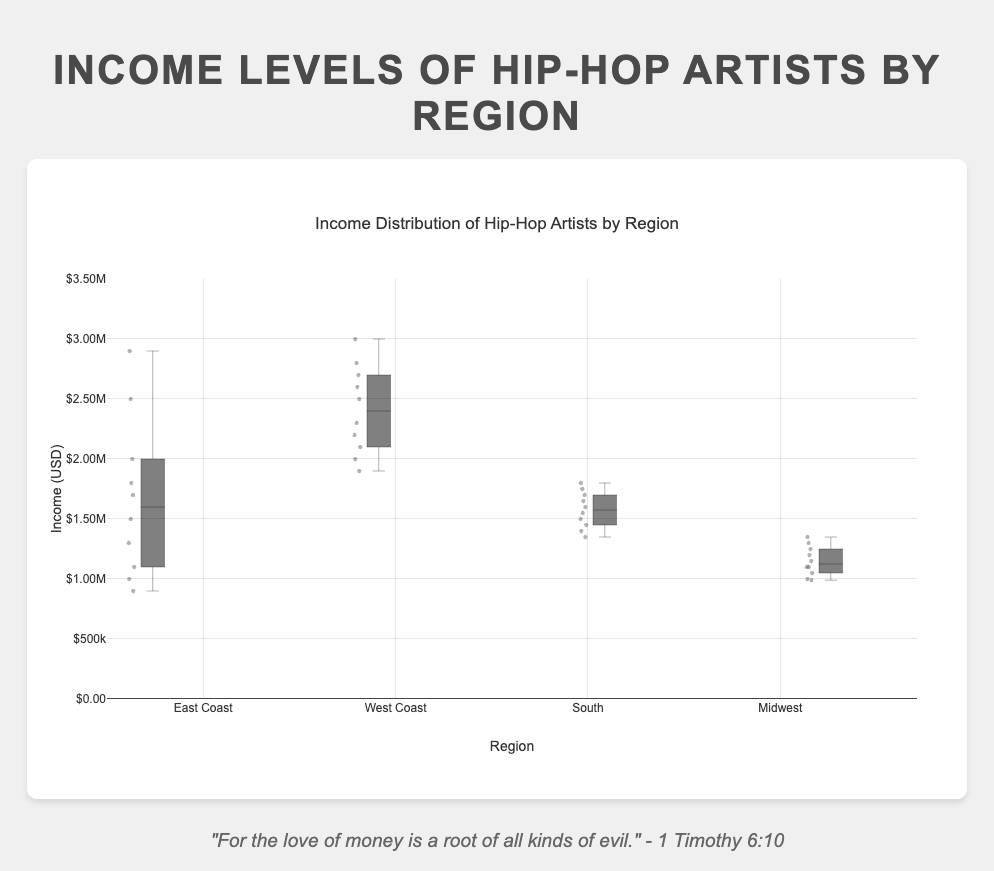What's the title of the chart? The title of the chart is visible at the top and reads "Income Distribution of Hip-Hop Artists by Region."
Answer: Income Distribution of Hip-Hop Artists by Region Which region has the highest upper quartile for income levels? The upper quartile for each region is represented by the top edge of the box in the box plot. The West Coast's box has the highest top edge, showing the highest upper quartile.
Answer: West Coast What is the median income level for the Midwest region? The median income level is indicated by the line inside the box for each region. In the Midwest region's box, this line is at 1,120,000 USD.
Answer: 1,120,000 USD Which region shows the widest range of income levels? The range of income levels is represented by the length of the box in each region's plot. The East Coast has the largest box, indicating the widest range of income levels.
Answer: East Coast Compare the range of income levels between the East Coast and Midwest regions. Which one is larger and by how much? The range is calculated by subtracting the minimum value from the maximum value. The East Coast's range is 2,900,000 - 900,000 = 2,000,000 USD. The Midwest's range is 1,350,000 - 990,000 = 360,000 USD. The difference is 2,000,000 USD - 360,000 USD = 1,640,000 USD, so East Coast has a larger range by 1,640,000 USD.
Answer: East Coast by 1,640,000 USD Identify the region with the smallest median income. The median is the line inside each box. The Midwest region has the lowest median line among all regions.
Answer: Midwest Which artist in the East Coast has the highest income, and what is the amount? The highest individual income point in the East Coast plot is annotated with "hoverinfo: 'text+y'" and corresponds to 50 Cent with an income of 2,900,000 USD.
Answer: 50 Cent, 2,900,000 USD What is the interquartile range (IQR) for the South region? The IQR is calculated as the difference between the third quartile (top edge of the box) and the first quartile (bottom edge of the box). For the South region, the top edge is at 1,650,000 and the bottom edge is at 1,400,000. The IQR is 1,650,000 - 1,400,000 = 250,000 USD.
Answer: 250,000 USD 